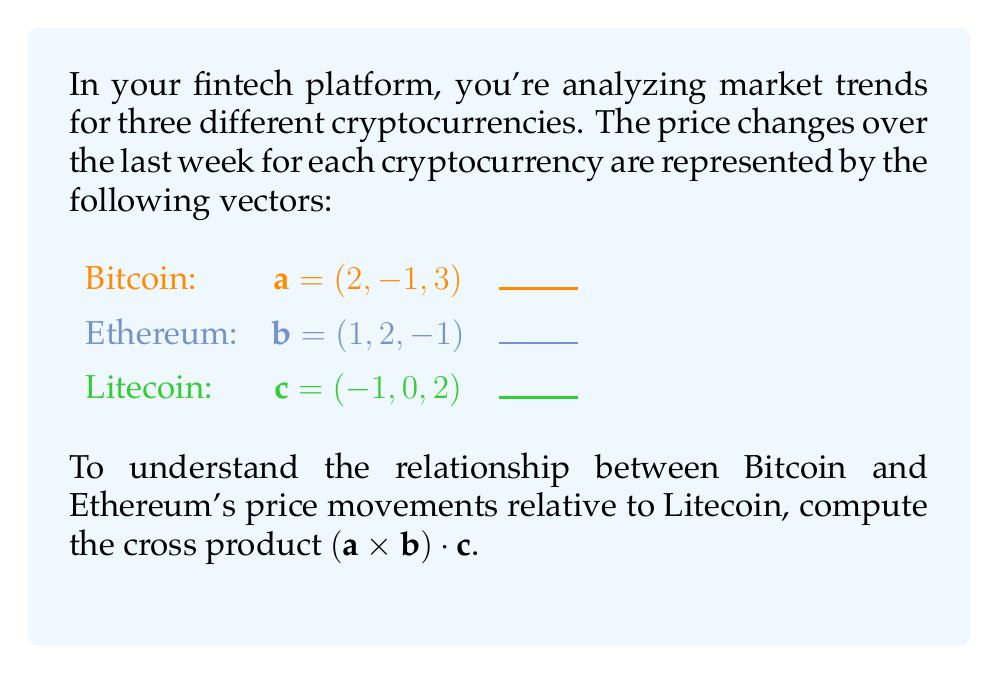Teach me how to tackle this problem. Let's approach this step-by-step:

1) First, we need to compute the cross product $\mathbf{a} \times \mathbf{b}$. The cross product of two vectors $\mathbf{a} = (a_1, a_2, a_3)$ and $\mathbf{b} = (b_1, b_2, b_3)$ is given by:

   $\mathbf{a} \times \mathbf{b} = (a_2b_3 - a_3b_2, a_3b_1 - a_1b_3, a_1b_2 - a_2b_1)$

2) Substituting the values:
   $\mathbf{a} \times \mathbf{b} = ((-1)(-1) - (3)(2), (3)(1) - (2)(-1), (2)(2) - (-1)(1))$

3) Simplifying:
   $\mathbf{a} \times \mathbf{b} = (1 - 6, 3 - (-2), 4 - (-1)) = (-5, 5, 5)$

4) Now we need to compute the dot product of this result with $\mathbf{c}$. The dot product of two vectors $\mathbf{p} = (p_1, p_2, p_3)$ and $\mathbf{q} = (q_1, q_2, q_3)$ is given by:

   $\mathbf{p} \cdot \mathbf{q} = p_1q_1 + p_2q_2 + p_3q_3$

5) So, we compute $(-5, 5, 5) \cdot (-1, 0, 2)$:
   $(-5)(-1) + (5)(0) + (5)(2)$

6) Simplifying:
   $5 + 0 + 10 = 15$

Therefore, $(\mathbf{a} \times \mathbf{b}) \cdot \mathbf{c} = 15$.
Answer: $15$ 